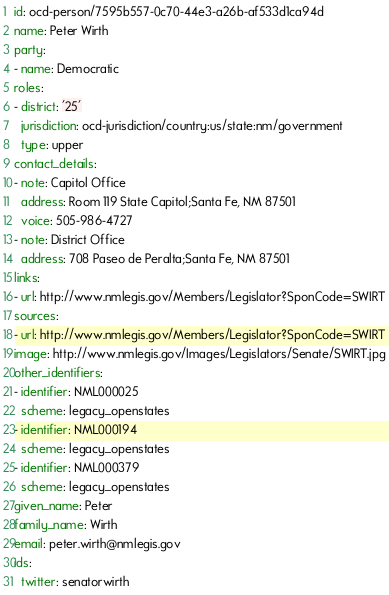<code> <loc_0><loc_0><loc_500><loc_500><_YAML_>id: ocd-person/7595b557-0c70-44e3-a26b-af533d1ca94d
name: Peter Wirth
party:
- name: Democratic
roles:
- district: '25'
  jurisdiction: ocd-jurisdiction/country:us/state:nm/government
  type: upper
contact_details:
- note: Capitol Office
  address: Room 119 State Capitol;Santa Fe, NM 87501
  voice: 505-986-4727
- note: District Office
  address: 708 Paseo de Peralta;Santa Fe, NM 87501
links:
- url: http://www.nmlegis.gov/Members/Legislator?SponCode=SWIRT
sources:
- url: http://www.nmlegis.gov/Members/Legislator?SponCode=SWIRT
image: http://www.nmlegis.gov/Images/Legislators/Senate/SWIRT.jpg
other_identifiers:
- identifier: NML000025
  scheme: legacy_openstates
- identifier: NML000194
  scheme: legacy_openstates
- identifier: NML000379
  scheme: legacy_openstates
given_name: Peter
family_name: Wirth
email: peter.wirth@nmlegis.gov
ids:
  twitter: senatorwirth
</code> 